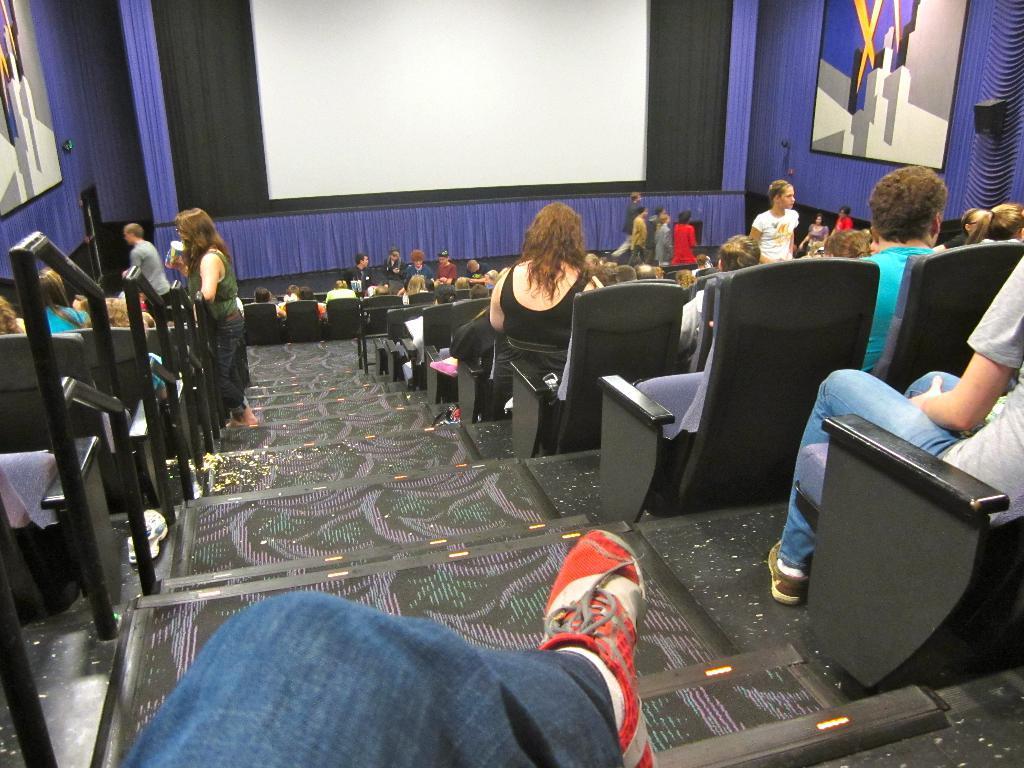Can you describe this image briefly? There are steps. Near to the steps there are chairs. There are many people sitting on the chairs. In the back there is a screen. Also there are curtains. 